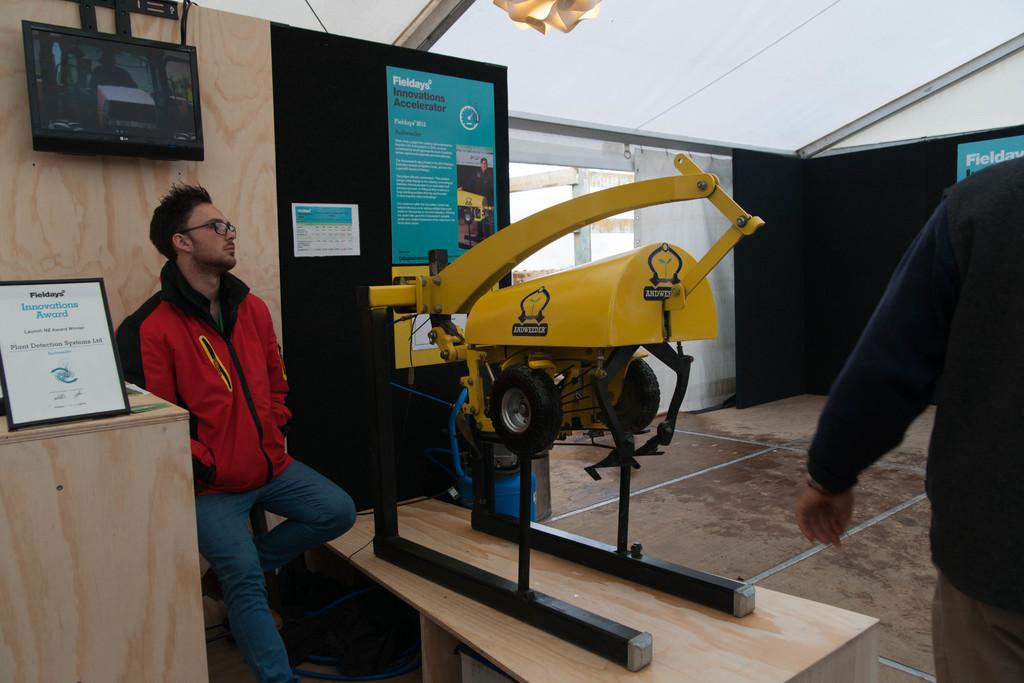What is the position of the man in the image? The man is standing in the image. What surface is the man standing on? The man is standing on the floor. Where is the man located in relation to the table? The man is beside a table. What can be seen on the wall in the image? There is a TV on the wall in the image. What object is on the table in the image? There is a machine on the table in the image. Is the man wearing a veil in the image? No, the man is not wearing a veil in the image. What type of rod is being used to control the machine on the table? There is no rod present in the image; the machine on the table does not require a rod for control. 